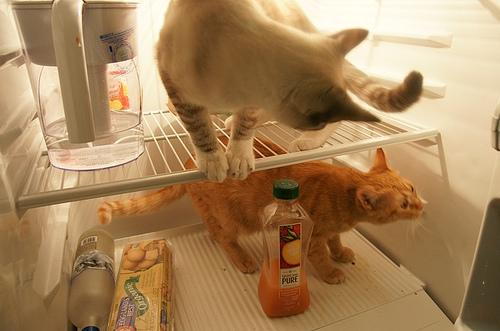Mention what type of liquid is present in the pitcher and any specific features of the pitcher. There is clean water in the pitcher, which has a white handle and a filter. For the task of visual entailment, describe whether the given image entails, contradicts, or is neutral to the statement "The refrigerator is empty." The image contradicts the statement "The refrigerator is empty," as it contains cats and various items. Which type of juice can be found in one of the bottles in the refrigerator? Mention the color of the lid too. Orange juice is in the bottle, and it has a green lid. In a multi-choice VQA task, choose the correct color of the handle and base part of the water pitcher in the fridge: a) Blue and white b) White and red c) White and black d) None of the above. The correct color of the handle and base part of the water pitcher is d) None of the above. It has a white handle and base. Explain the appearance of the two cats located in the refrigerator. One cat is orange with beige stripes and orange ears and paws, while the other cat is white and grey with a grey and brown tail. Identify the type of animals present in the image and what they're doing. Two cats, one orange and the other white and grey, are playing inside a refrigerator on the wire shelf. In a product advertisement task, describe the white shelf in the fridge. The white shelf in the fridge is spacious and sturdy, perfect for storing a variety of items, and enhancing the interior organization of the refrigerator. List the items you can find inside the fridge in the given image. There are two cats, a carton of eggs, a bottle of orange juice, a pitcher of water, and a bottle of vodka in the fridge. 